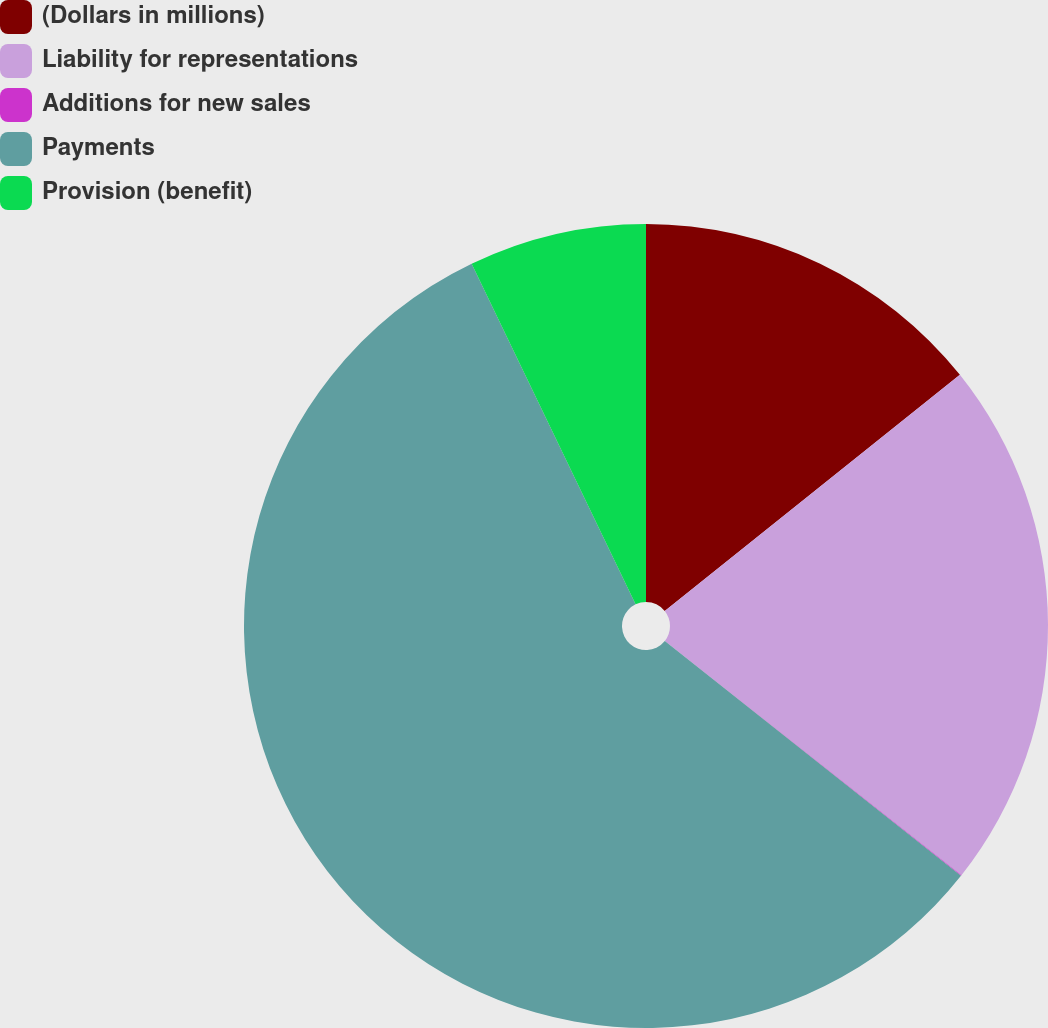Convert chart. <chart><loc_0><loc_0><loc_500><loc_500><pie_chart><fcel>(Dollars in millions)<fcel>Liability for representations<fcel>Additions for new sales<fcel>Payments<fcel>Provision (benefit)<nl><fcel>14.26%<fcel>21.38%<fcel>0.03%<fcel>57.19%<fcel>7.14%<nl></chart> 